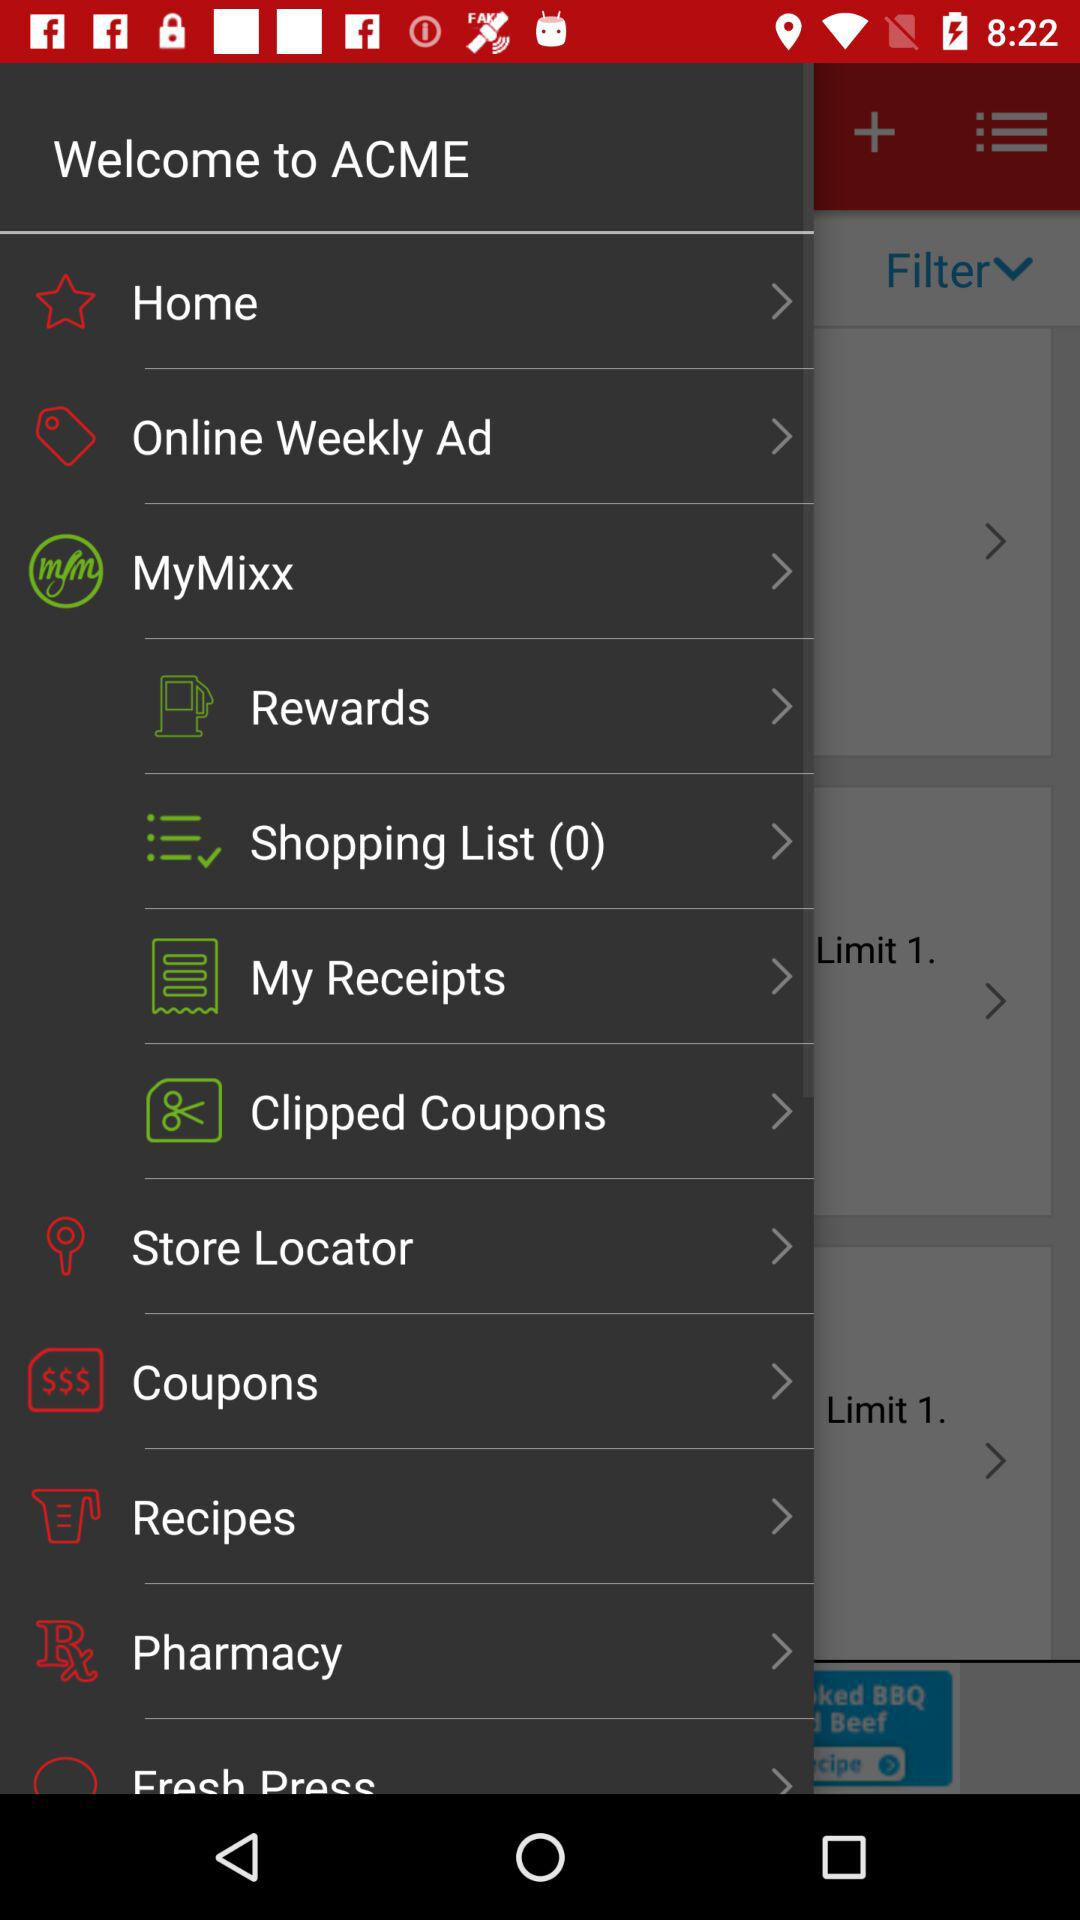How many clipped coupons does the user have?
When the provided information is insufficient, respond with <no answer>. <no answer> 